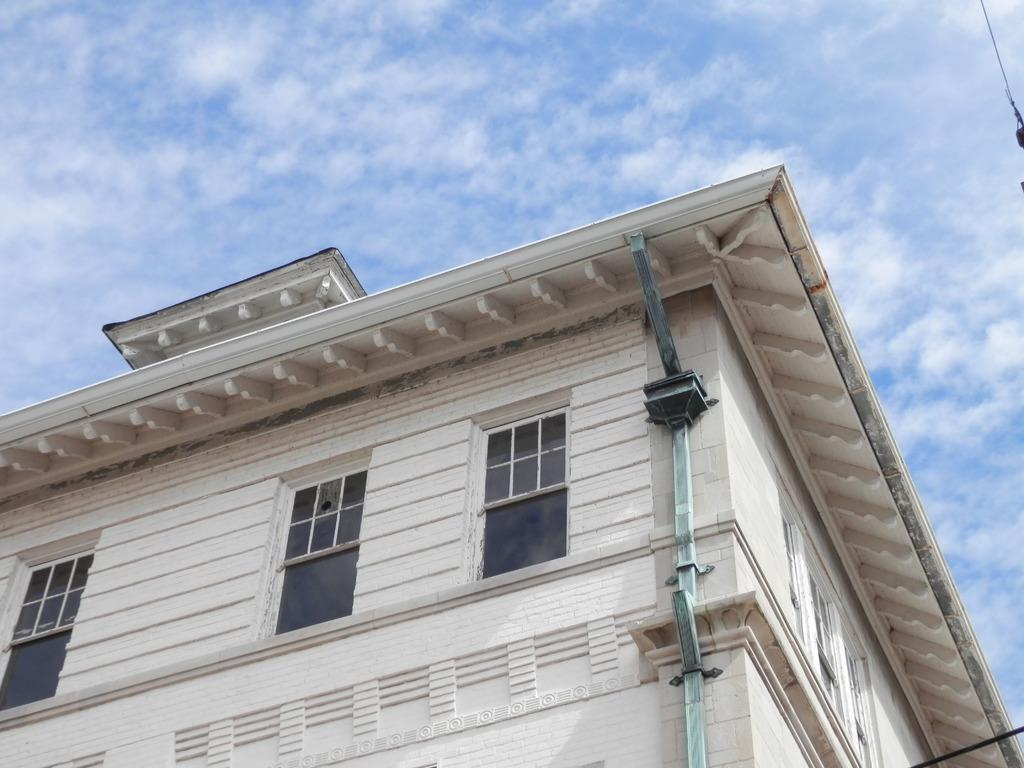What is the main subject in the center of the image? There is a building in the center of the image. What is the condition of the sky in the image? The sky is cloudy in the image. How many legs can be seen on the building in the image? Buildings do not have legs, so there are no legs visible on the building in the image. 